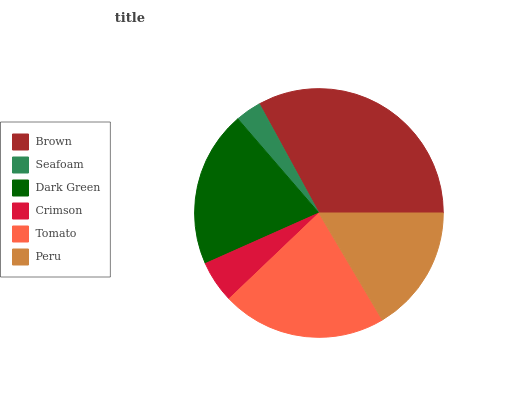Is Seafoam the minimum?
Answer yes or no. Yes. Is Brown the maximum?
Answer yes or no. Yes. Is Dark Green the minimum?
Answer yes or no. No. Is Dark Green the maximum?
Answer yes or no. No. Is Dark Green greater than Seafoam?
Answer yes or no. Yes. Is Seafoam less than Dark Green?
Answer yes or no. Yes. Is Seafoam greater than Dark Green?
Answer yes or no. No. Is Dark Green less than Seafoam?
Answer yes or no. No. Is Dark Green the high median?
Answer yes or no. Yes. Is Peru the low median?
Answer yes or no. Yes. Is Tomato the high median?
Answer yes or no. No. Is Tomato the low median?
Answer yes or no. No. 